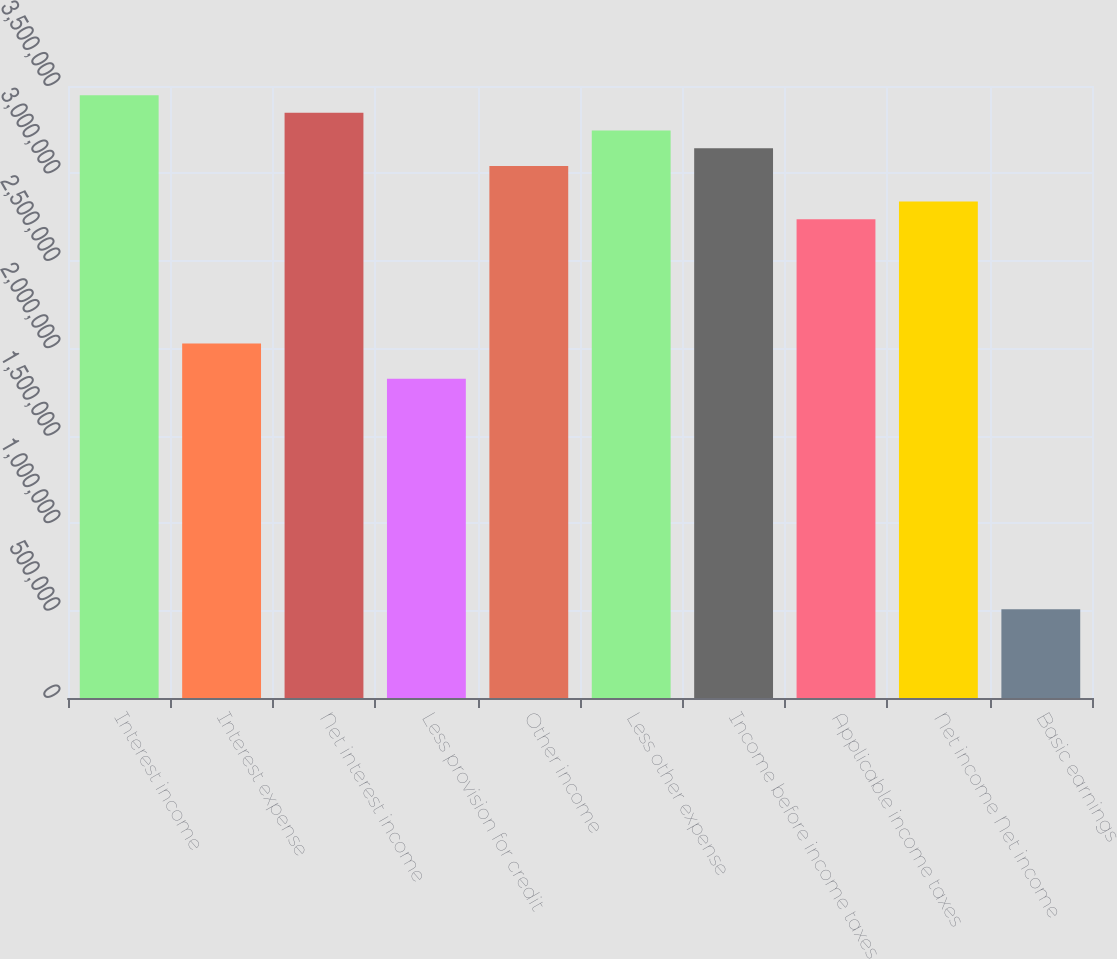<chart> <loc_0><loc_0><loc_500><loc_500><bar_chart><fcel>Interest income<fcel>Interest expense<fcel>Net interest income<fcel>Less provision for credit<fcel>Other income<fcel>Less other expense<fcel>Income before income taxes<fcel>Applicable income taxes<fcel>Net income Net income<fcel>Basic earnings<nl><fcel>3.44771e+06<fcel>2.02806e+06<fcel>3.3463e+06<fcel>1.82526e+06<fcel>3.04209e+06<fcel>3.2449e+06<fcel>3.1435e+06<fcel>2.73789e+06<fcel>2.83929e+06<fcel>507016<nl></chart> 